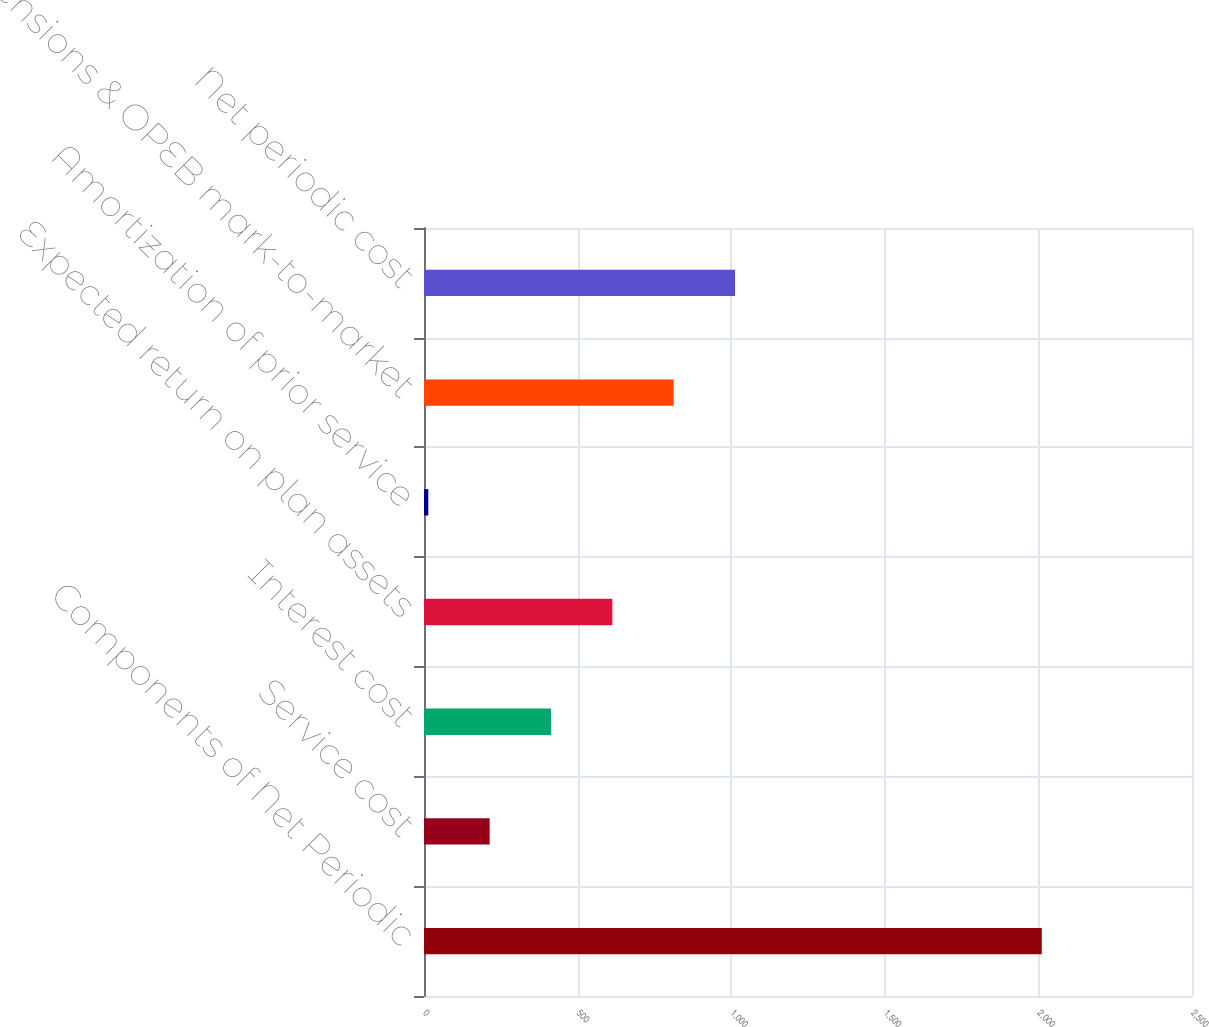Convert chart. <chart><loc_0><loc_0><loc_500><loc_500><bar_chart><fcel>Components of Net Periodic<fcel>Service cost<fcel>Interest cost<fcel>Expected return on plan assets<fcel>Amortization of prior service<fcel>Pensions & OPEB mark-to-market<fcel>Net periodic cost<nl><fcel>2011<fcel>213.7<fcel>413.4<fcel>613.1<fcel>14<fcel>812.8<fcel>1012.5<nl></chart> 